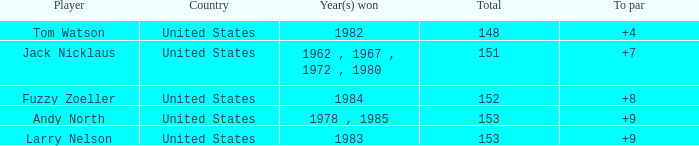What is the overall total for the player with a victory in 1982? 148.0. 